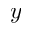<formula> <loc_0><loc_0><loc_500><loc_500>y</formula> 